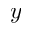<formula> <loc_0><loc_0><loc_500><loc_500>y</formula> 